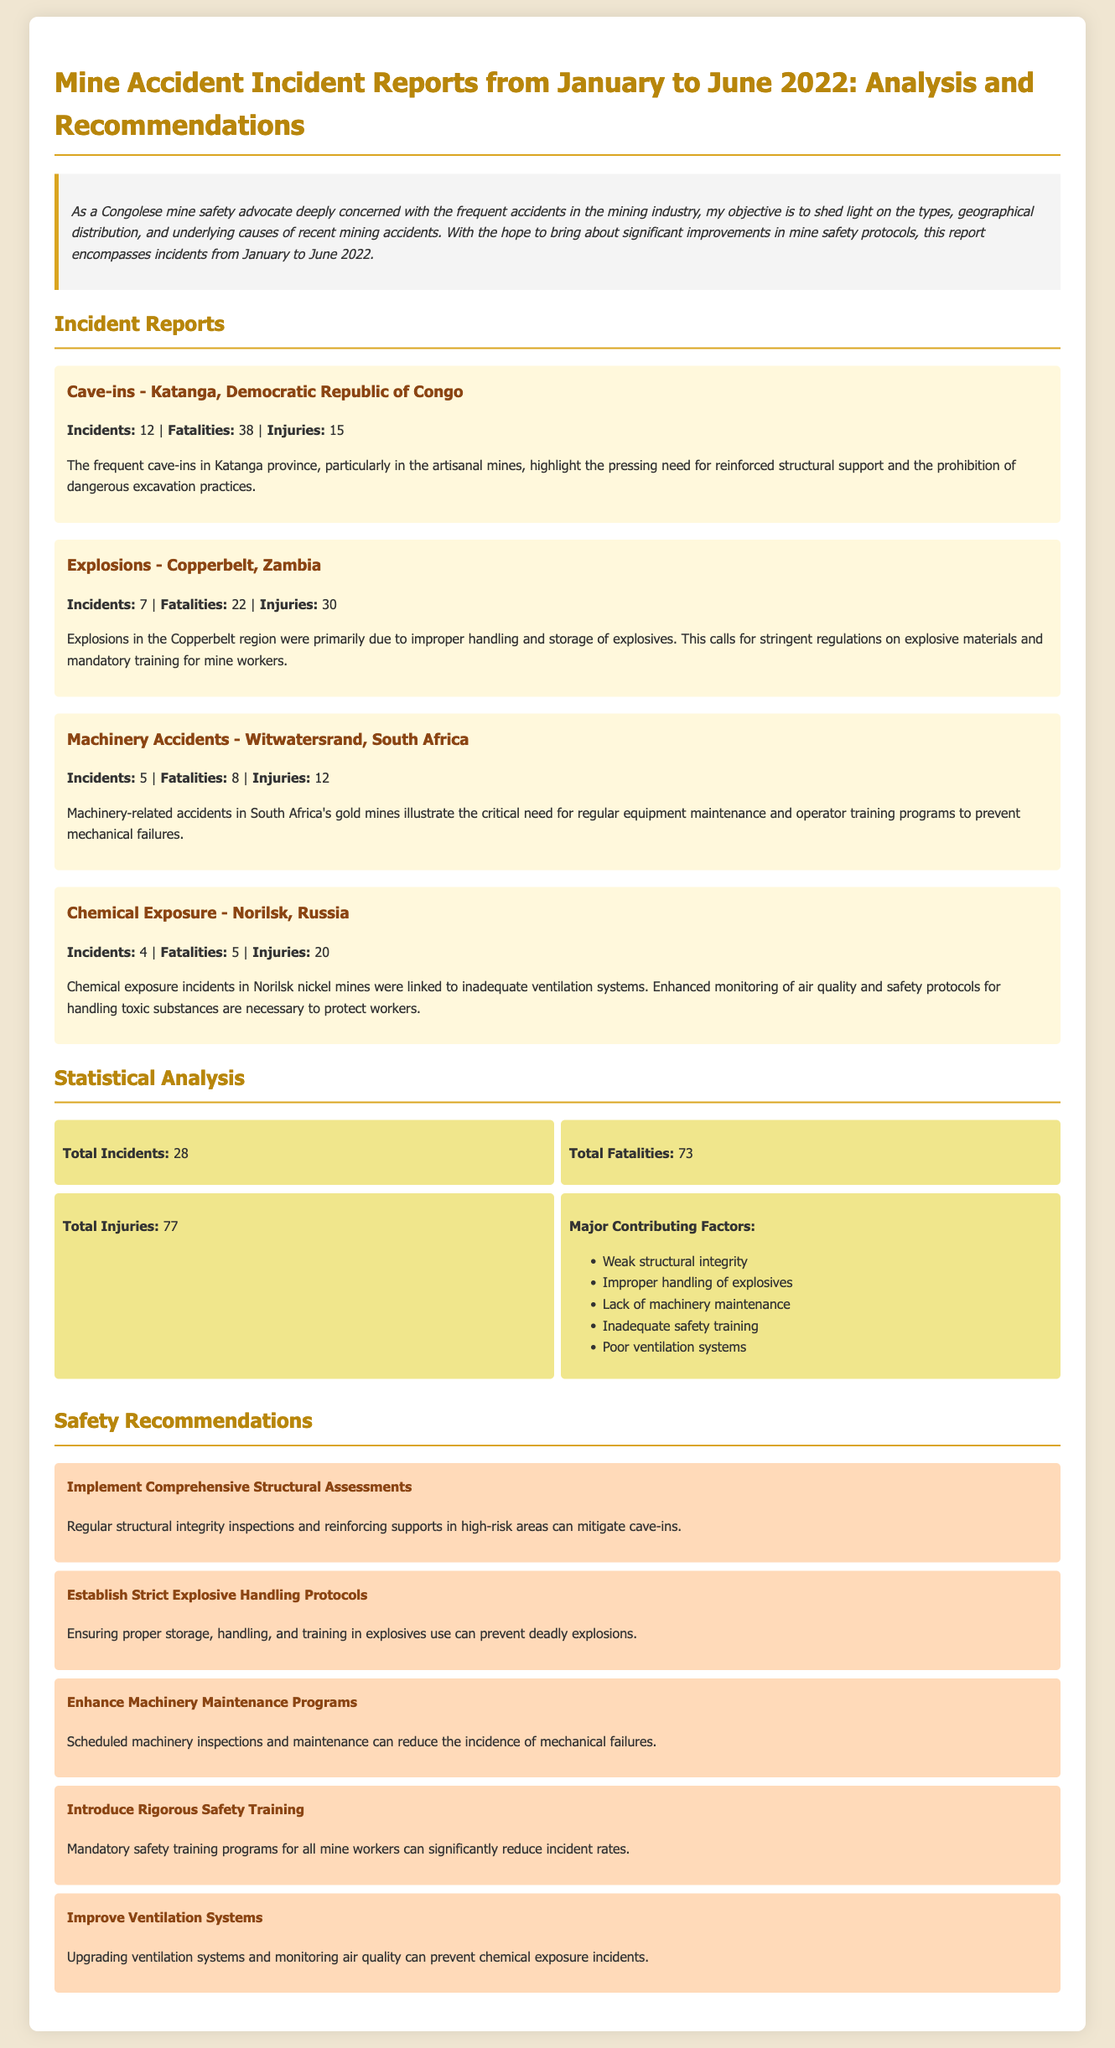what is the total number of incidents reported? The total number of incidents reported is found in the statistics section, which adds up all types of accidents.
Answer: 28 how many fatalities were recorded for cave-ins in Katanga? The number of fatalities for cave-ins is provided in the incident report for Katanga.
Answer: 38 which geographical location had the highest number of fatalities? The geographical location with the highest number of fatalities is determined by comparing the fatalities across all incident reports.
Answer: Katanga, Democratic Republic of Congo how many injuries were caused by machinery accidents? The number of injuries from machinery accidents is specifically listed in the incident report for Witwatersrand.
Answer: 12 what is one major contributing factor to mine accidents? The document lists several contributing factors in the statistical analysis section.
Answer: Weak structural integrity what type of accidents occurred in Norilsk, Russia? The type of accidents in Norilsk is identified in the incident report section of the document.
Answer: Chemical Exposure how many total injuries were reported from January to June 2022? The total number of injuries is summed up in the statistics section of the report.
Answer: 77 what is one recommendation made to improve mine safety? A recommendation to improve mine safety is discussed in the safety recommendations section.
Answer: Implement Comprehensive Structural Assessments what was the number of incidents reported in the Copperbelt region, Zambia? The number of incidents in the Copperbelt region is stated in its specific incident report.
Answer: 7 how many incidents were linked to improper handling of explosives? The incidents related to improper handling of explosives are tied to explosions in the Copperbelt region.
Answer: 7 